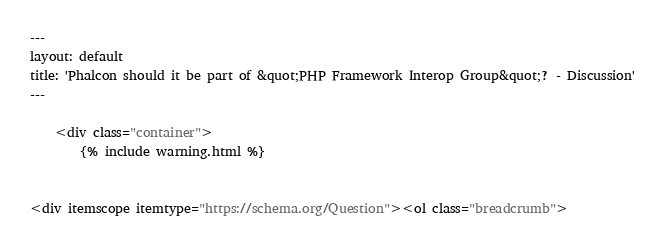<code> <loc_0><loc_0><loc_500><loc_500><_HTML_>---
layout: default
title: 'Phalcon should it be part of &quot;PHP Framework Interop Group&quot;? - Discussion'
---

    <div class="container">
        {% include warning.html %}


<div itemscope itemtype="https://schema.org/Question"><ol class="breadcrumb"></code> 